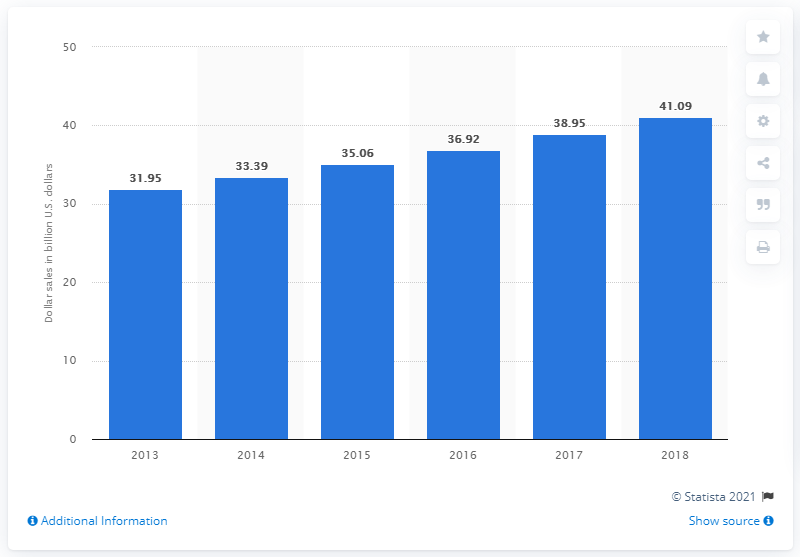List a handful of essential elements in this visual. The summation of the longest and shortest bar is 73.04. The retail sales of kids' food and beverages in the United States were lowest in 2013. The retail sales of children's food and beverages in the United States in 2013 was 31.95. 